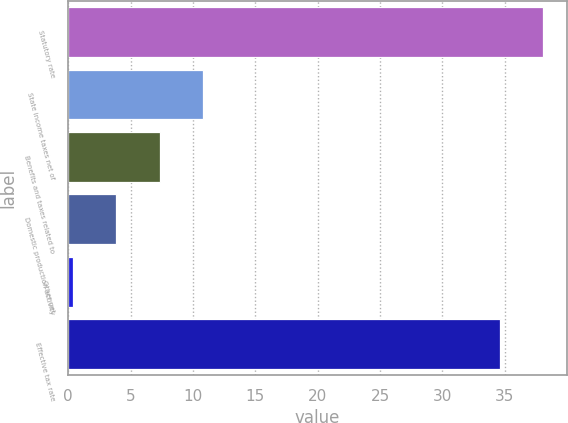Convert chart. <chart><loc_0><loc_0><loc_500><loc_500><bar_chart><fcel>Statutory rate<fcel>State income taxes net of<fcel>Benefits and taxes related to<fcel>Domestic production activity<fcel>Other net<fcel>Effective tax rate<nl><fcel>38.06<fcel>10.78<fcel>7.32<fcel>3.86<fcel>0.4<fcel>34.6<nl></chart> 